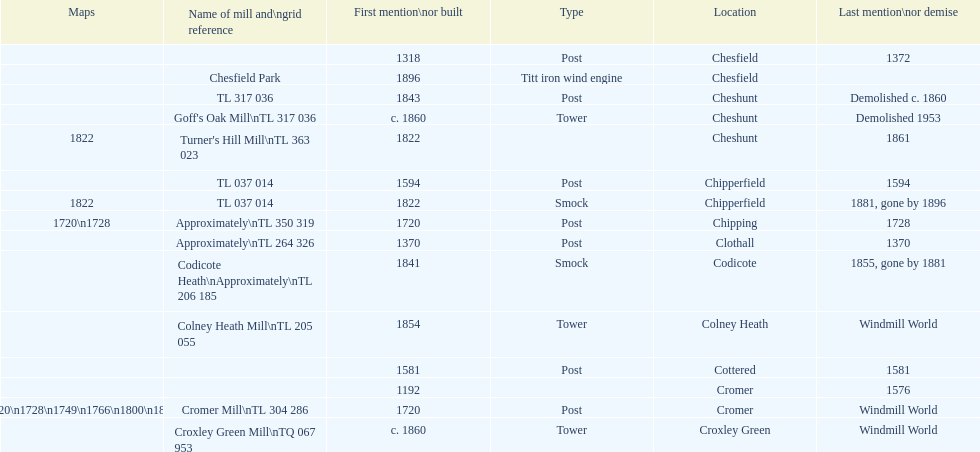How many locations have or had at least 2 windmills? 4. 